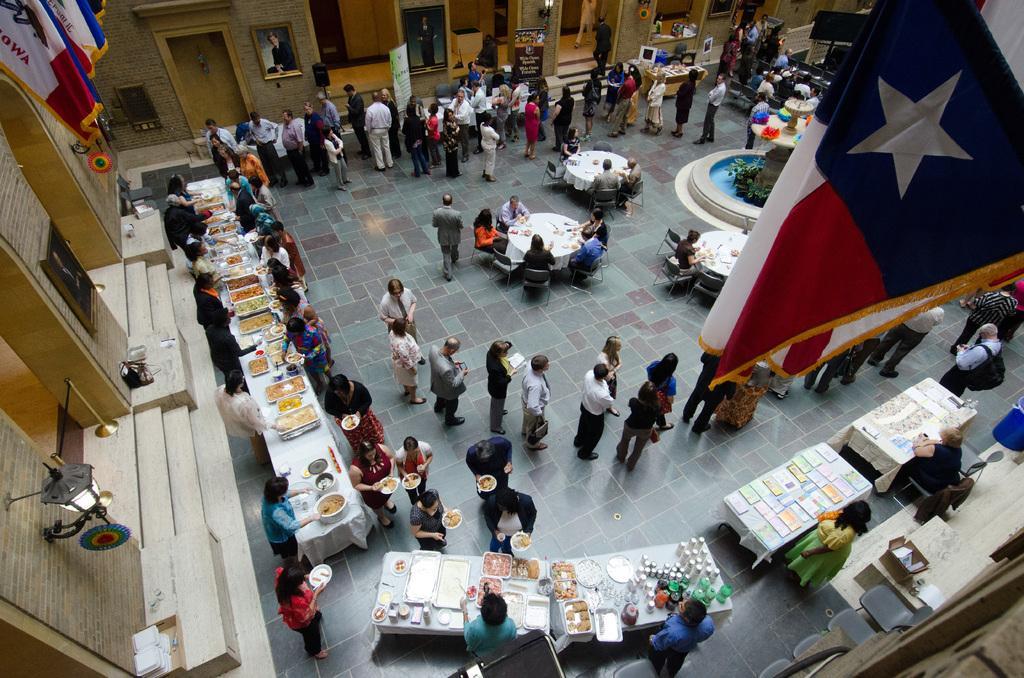Describe this image in one or two sentences. The photo is clicked on the top of the big hall. There are foods on the tables. In the middle there are dining table around it there are chairs. People are sitting on chairs. People are standing in front of the tables. Here there is a flag. On the wall there are photo frames. 